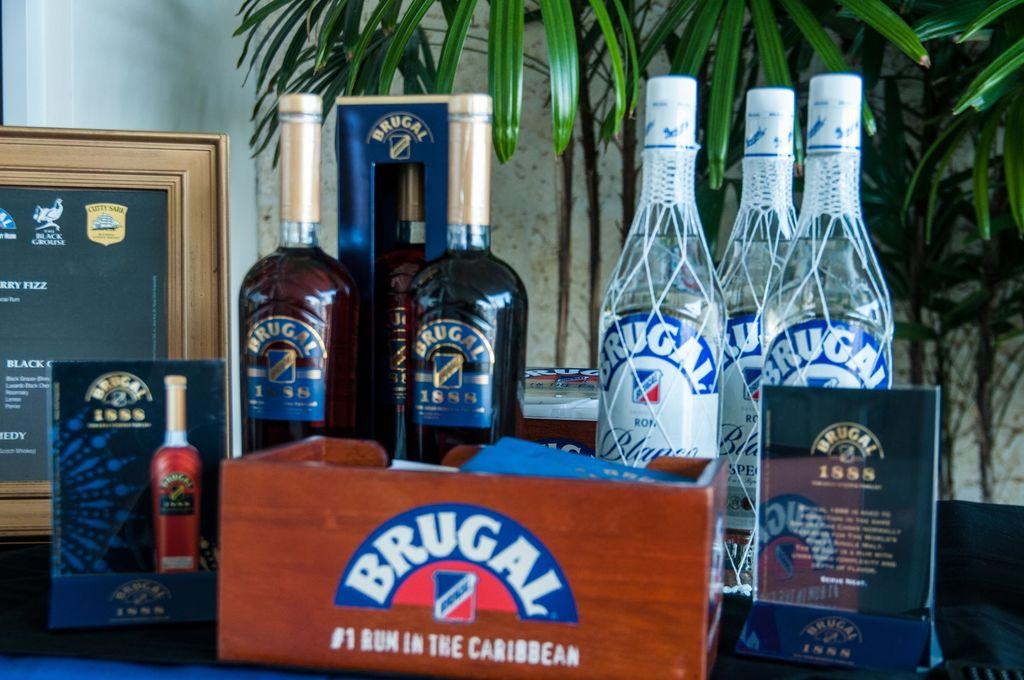<image>
Render a clear and concise summary of the photo. A wooden box with Brugal on it sits in front of bottles. 